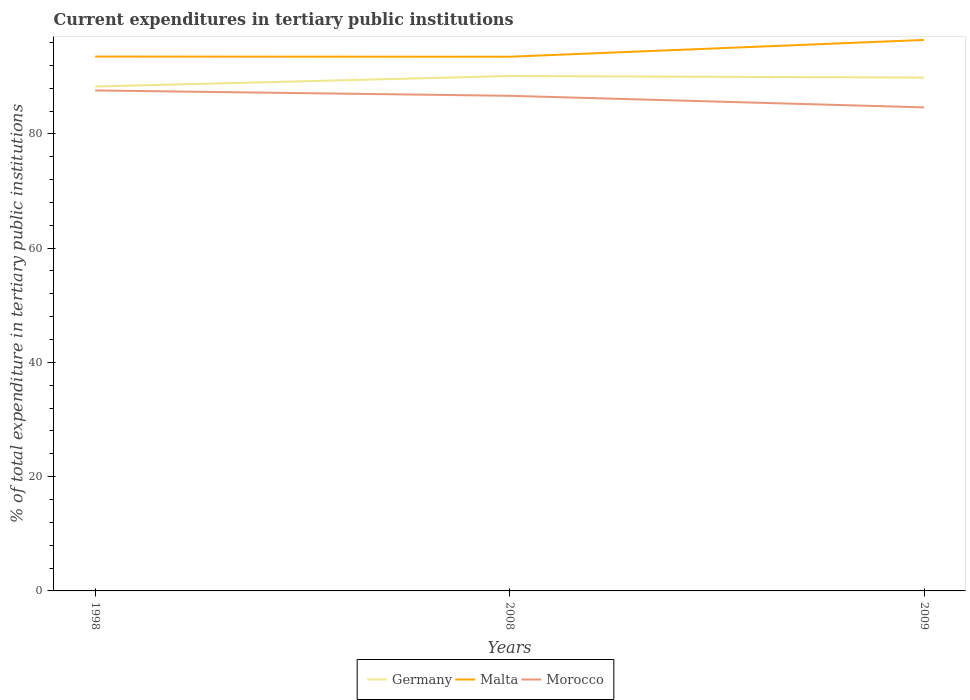Does the line corresponding to Morocco intersect with the line corresponding to Germany?
Provide a succinct answer. No. Is the number of lines equal to the number of legend labels?
Provide a short and direct response. Yes. Across all years, what is the maximum current expenditures in tertiary public institutions in Malta?
Make the answer very short. 93.5. What is the total current expenditures in tertiary public institutions in Malta in the graph?
Give a very brief answer. 0.02. What is the difference between the highest and the second highest current expenditures in tertiary public institutions in Malta?
Your answer should be compact. 2.94. Is the current expenditures in tertiary public institutions in Germany strictly greater than the current expenditures in tertiary public institutions in Morocco over the years?
Keep it short and to the point. No. What is the difference between two consecutive major ticks on the Y-axis?
Your answer should be compact. 20. Are the values on the major ticks of Y-axis written in scientific E-notation?
Ensure brevity in your answer.  No. Does the graph contain any zero values?
Provide a succinct answer. No. Where does the legend appear in the graph?
Ensure brevity in your answer.  Bottom center. How are the legend labels stacked?
Offer a very short reply. Horizontal. What is the title of the graph?
Offer a very short reply. Current expenditures in tertiary public institutions. Does "Sub-Saharan Africa (all income levels)" appear as one of the legend labels in the graph?
Your response must be concise. No. What is the label or title of the X-axis?
Give a very brief answer. Years. What is the label or title of the Y-axis?
Offer a terse response. % of total expenditure in tertiary public institutions. What is the % of total expenditure in tertiary public institutions in Germany in 1998?
Your answer should be very brief. 88.29. What is the % of total expenditure in tertiary public institutions in Malta in 1998?
Ensure brevity in your answer.  93.53. What is the % of total expenditure in tertiary public institutions of Morocco in 1998?
Provide a succinct answer. 87.6. What is the % of total expenditure in tertiary public institutions in Germany in 2008?
Give a very brief answer. 90.12. What is the % of total expenditure in tertiary public institutions of Malta in 2008?
Provide a succinct answer. 93.5. What is the % of total expenditure in tertiary public institutions of Morocco in 2008?
Your response must be concise. 86.66. What is the % of total expenditure in tertiary public institutions of Germany in 2009?
Make the answer very short. 89.86. What is the % of total expenditure in tertiary public institutions of Malta in 2009?
Your response must be concise. 96.44. What is the % of total expenditure in tertiary public institutions of Morocco in 2009?
Your answer should be compact. 84.64. Across all years, what is the maximum % of total expenditure in tertiary public institutions in Germany?
Your answer should be very brief. 90.12. Across all years, what is the maximum % of total expenditure in tertiary public institutions in Malta?
Your answer should be compact. 96.44. Across all years, what is the maximum % of total expenditure in tertiary public institutions of Morocco?
Ensure brevity in your answer.  87.6. Across all years, what is the minimum % of total expenditure in tertiary public institutions of Germany?
Make the answer very short. 88.29. Across all years, what is the minimum % of total expenditure in tertiary public institutions in Malta?
Provide a succinct answer. 93.5. Across all years, what is the minimum % of total expenditure in tertiary public institutions of Morocco?
Keep it short and to the point. 84.64. What is the total % of total expenditure in tertiary public institutions of Germany in the graph?
Offer a terse response. 268.27. What is the total % of total expenditure in tertiary public institutions of Malta in the graph?
Give a very brief answer. 283.47. What is the total % of total expenditure in tertiary public institutions of Morocco in the graph?
Your answer should be compact. 258.9. What is the difference between the % of total expenditure in tertiary public institutions in Germany in 1998 and that in 2008?
Offer a terse response. -1.83. What is the difference between the % of total expenditure in tertiary public institutions in Malta in 1998 and that in 2008?
Provide a short and direct response. 0.02. What is the difference between the % of total expenditure in tertiary public institutions of Morocco in 1998 and that in 2008?
Make the answer very short. 0.94. What is the difference between the % of total expenditure in tertiary public institutions in Germany in 1998 and that in 2009?
Your response must be concise. -1.57. What is the difference between the % of total expenditure in tertiary public institutions in Malta in 1998 and that in 2009?
Ensure brevity in your answer.  -2.91. What is the difference between the % of total expenditure in tertiary public institutions in Morocco in 1998 and that in 2009?
Make the answer very short. 2.96. What is the difference between the % of total expenditure in tertiary public institutions of Germany in 2008 and that in 2009?
Make the answer very short. 0.26. What is the difference between the % of total expenditure in tertiary public institutions in Malta in 2008 and that in 2009?
Your response must be concise. -2.94. What is the difference between the % of total expenditure in tertiary public institutions of Morocco in 2008 and that in 2009?
Ensure brevity in your answer.  2.02. What is the difference between the % of total expenditure in tertiary public institutions in Germany in 1998 and the % of total expenditure in tertiary public institutions in Malta in 2008?
Provide a succinct answer. -5.21. What is the difference between the % of total expenditure in tertiary public institutions in Germany in 1998 and the % of total expenditure in tertiary public institutions in Morocco in 2008?
Provide a short and direct response. 1.63. What is the difference between the % of total expenditure in tertiary public institutions of Malta in 1998 and the % of total expenditure in tertiary public institutions of Morocco in 2008?
Ensure brevity in your answer.  6.86. What is the difference between the % of total expenditure in tertiary public institutions of Germany in 1998 and the % of total expenditure in tertiary public institutions of Malta in 2009?
Provide a short and direct response. -8.15. What is the difference between the % of total expenditure in tertiary public institutions of Germany in 1998 and the % of total expenditure in tertiary public institutions of Morocco in 2009?
Offer a very short reply. 3.65. What is the difference between the % of total expenditure in tertiary public institutions of Malta in 1998 and the % of total expenditure in tertiary public institutions of Morocco in 2009?
Give a very brief answer. 8.89. What is the difference between the % of total expenditure in tertiary public institutions of Germany in 2008 and the % of total expenditure in tertiary public institutions of Malta in 2009?
Your response must be concise. -6.32. What is the difference between the % of total expenditure in tertiary public institutions of Germany in 2008 and the % of total expenditure in tertiary public institutions of Morocco in 2009?
Make the answer very short. 5.48. What is the difference between the % of total expenditure in tertiary public institutions of Malta in 2008 and the % of total expenditure in tertiary public institutions of Morocco in 2009?
Your response must be concise. 8.86. What is the average % of total expenditure in tertiary public institutions of Germany per year?
Keep it short and to the point. 89.42. What is the average % of total expenditure in tertiary public institutions of Malta per year?
Keep it short and to the point. 94.49. What is the average % of total expenditure in tertiary public institutions in Morocco per year?
Give a very brief answer. 86.3. In the year 1998, what is the difference between the % of total expenditure in tertiary public institutions in Germany and % of total expenditure in tertiary public institutions in Malta?
Provide a short and direct response. -5.24. In the year 1998, what is the difference between the % of total expenditure in tertiary public institutions in Germany and % of total expenditure in tertiary public institutions in Morocco?
Your answer should be very brief. 0.69. In the year 1998, what is the difference between the % of total expenditure in tertiary public institutions in Malta and % of total expenditure in tertiary public institutions in Morocco?
Offer a terse response. 5.93. In the year 2008, what is the difference between the % of total expenditure in tertiary public institutions in Germany and % of total expenditure in tertiary public institutions in Malta?
Offer a very short reply. -3.38. In the year 2008, what is the difference between the % of total expenditure in tertiary public institutions of Germany and % of total expenditure in tertiary public institutions of Morocco?
Offer a very short reply. 3.46. In the year 2008, what is the difference between the % of total expenditure in tertiary public institutions of Malta and % of total expenditure in tertiary public institutions of Morocco?
Make the answer very short. 6.84. In the year 2009, what is the difference between the % of total expenditure in tertiary public institutions of Germany and % of total expenditure in tertiary public institutions of Malta?
Provide a succinct answer. -6.58. In the year 2009, what is the difference between the % of total expenditure in tertiary public institutions of Germany and % of total expenditure in tertiary public institutions of Morocco?
Provide a short and direct response. 5.22. In the year 2009, what is the difference between the % of total expenditure in tertiary public institutions in Malta and % of total expenditure in tertiary public institutions in Morocco?
Offer a very short reply. 11.8. What is the ratio of the % of total expenditure in tertiary public institutions in Germany in 1998 to that in 2008?
Keep it short and to the point. 0.98. What is the ratio of the % of total expenditure in tertiary public institutions in Morocco in 1998 to that in 2008?
Offer a terse response. 1.01. What is the ratio of the % of total expenditure in tertiary public institutions in Germany in 1998 to that in 2009?
Offer a very short reply. 0.98. What is the ratio of the % of total expenditure in tertiary public institutions in Malta in 1998 to that in 2009?
Give a very brief answer. 0.97. What is the ratio of the % of total expenditure in tertiary public institutions of Morocco in 1998 to that in 2009?
Provide a succinct answer. 1.03. What is the ratio of the % of total expenditure in tertiary public institutions of Germany in 2008 to that in 2009?
Offer a very short reply. 1. What is the ratio of the % of total expenditure in tertiary public institutions in Malta in 2008 to that in 2009?
Keep it short and to the point. 0.97. What is the ratio of the % of total expenditure in tertiary public institutions in Morocco in 2008 to that in 2009?
Ensure brevity in your answer.  1.02. What is the difference between the highest and the second highest % of total expenditure in tertiary public institutions of Germany?
Provide a short and direct response. 0.26. What is the difference between the highest and the second highest % of total expenditure in tertiary public institutions in Malta?
Make the answer very short. 2.91. What is the difference between the highest and the second highest % of total expenditure in tertiary public institutions in Morocco?
Your answer should be compact. 0.94. What is the difference between the highest and the lowest % of total expenditure in tertiary public institutions in Germany?
Offer a very short reply. 1.83. What is the difference between the highest and the lowest % of total expenditure in tertiary public institutions in Malta?
Ensure brevity in your answer.  2.94. What is the difference between the highest and the lowest % of total expenditure in tertiary public institutions in Morocco?
Ensure brevity in your answer.  2.96. 